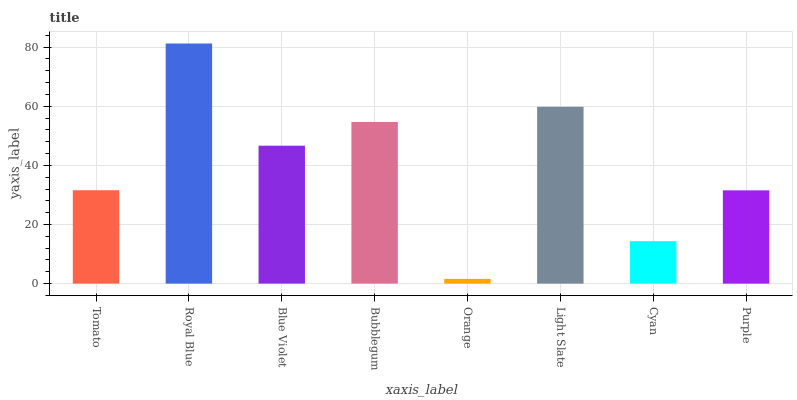Is Orange the minimum?
Answer yes or no. Yes. Is Royal Blue the maximum?
Answer yes or no. Yes. Is Blue Violet the minimum?
Answer yes or no. No. Is Blue Violet the maximum?
Answer yes or no. No. Is Royal Blue greater than Blue Violet?
Answer yes or no. Yes. Is Blue Violet less than Royal Blue?
Answer yes or no. Yes. Is Blue Violet greater than Royal Blue?
Answer yes or no. No. Is Royal Blue less than Blue Violet?
Answer yes or no. No. Is Blue Violet the high median?
Answer yes or no. Yes. Is Tomato the low median?
Answer yes or no. Yes. Is Bubblegum the high median?
Answer yes or no. No. Is Cyan the low median?
Answer yes or no. No. 